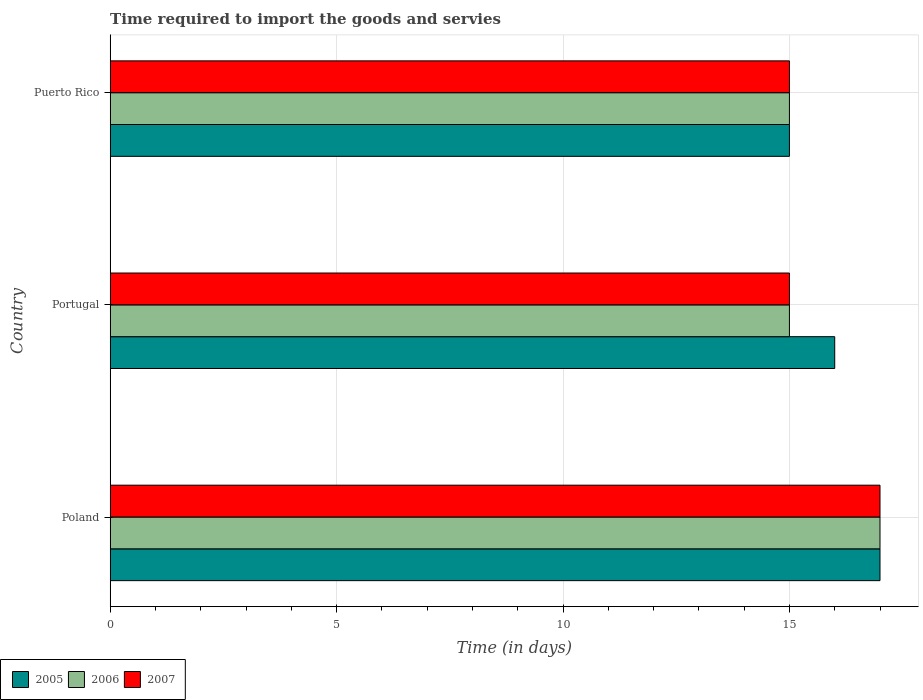How many different coloured bars are there?
Offer a very short reply. 3. How many groups of bars are there?
Your answer should be very brief. 3. Are the number of bars per tick equal to the number of legend labels?
Offer a very short reply. Yes. How many bars are there on the 2nd tick from the top?
Offer a very short reply. 3. How many bars are there on the 1st tick from the bottom?
Your answer should be very brief. 3. What is the label of the 1st group of bars from the top?
Your answer should be very brief. Puerto Rico. In how many cases, is the number of bars for a given country not equal to the number of legend labels?
Keep it short and to the point. 0. What is the number of days required to import the goods and services in 2005 in Poland?
Give a very brief answer. 17. Across all countries, what is the minimum number of days required to import the goods and services in 2005?
Your answer should be compact. 15. In which country was the number of days required to import the goods and services in 2005 minimum?
Your response must be concise. Puerto Rico. What is the total number of days required to import the goods and services in 2005 in the graph?
Your response must be concise. 48. What is the average number of days required to import the goods and services in 2006 per country?
Offer a very short reply. 15.67. What is the ratio of the number of days required to import the goods and services in 2005 in Poland to that in Puerto Rico?
Your answer should be compact. 1.13. Is the number of days required to import the goods and services in 2006 in Poland less than that in Portugal?
Provide a succinct answer. No. What is the difference between the highest and the second highest number of days required to import the goods and services in 2007?
Your answer should be compact. 2. What does the 1st bar from the top in Portugal represents?
Your answer should be very brief. 2007. What does the 1st bar from the bottom in Portugal represents?
Provide a short and direct response. 2005. Is it the case that in every country, the sum of the number of days required to import the goods and services in 2006 and number of days required to import the goods and services in 2007 is greater than the number of days required to import the goods and services in 2005?
Offer a terse response. Yes. How many bars are there?
Ensure brevity in your answer.  9. Does the graph contain any zero values?
Your answer should be compact. No. How are the legend labels stacked?
Provide a short and direct response. Horizontal. What is the title of the graph?
Give a very brief answer. Time required to import the goods and servies. What is the label or title of the X-axis?
Offer a very short reply. Time (in days). What is the label or title of the Y-axis?
Give a very brief answer. Country. What is the Time (in days) in 2005 in Poland?
Offer a terse response. 17. What is the Time (in days) in 2007 in Poland?
Make the answer very short. 17. What is the Time (in days) in 2007 in Portugal?
Provide a short and direct response. 15. What is the Time (in days) in 2005 in Puerto Rico?
Your answer should be compact. 15. What is the Time (in days) in 2007 in Puerto Rico?
Your answer should be very brief. 15. Across all countries, what is the maximum Time (in days) of 2006?
Your response must be concise. 17. Across all countries, what is the minimum Time (in days) of 2006?
Offer a terse response. 15. What is the total Time (in days) in 2005 in the graph?
Your response must be concise. 48. What is the difference between the Time (in days) of 2005 in Poland and that in Portugal?
Your answer should be compact. 1. What is the difference between the Time (in days) in 2007 in Poland and that in Portugal?
Offer a terse response. 2. What is the difference between the Time (in days) of 2005 in Portugal and that in Puerto Rico?
Give a very brief answer. 1. What is the difference between the Time (in days) of 2005 in Portugal and the Time (in days) of 2006 in Puerto Rico?
Provide a succinct answer. 1. What is the average Time (in days) of 2006 per country?
Provide a short and direct response. 15.67. What is the average Time (in days) of 2007 per country?
Your response must be concise. 15.67. What is the difference between the Time (in days) in 2005 and Time (in days) in 2006 in Poland?
Provide a succinct answer. 0. What is the difference between the Time (in days) in 2005 and Time (in days) in 2007 in Poland?
Give a very brief answer. 0. What is the difference between the Time (in days) of 2006 and Time (in days) of 2007 in Portugal?
Offer a terse response. 0. What is the difference between the Time (in days) of 2005 and Time (in days) of 2007 in Puerto Rico?
Keep it short and to the point. 0. What is the ratio of the Time (in days) in 2005 in Poland to that in Portugal?
Your answer should be very brief. 1.06. What is the ratio of the Time (in days) in 2006 in Poland to that in Portugal?
Your answer should be very brief. 1.13. What is the ratio of the Time (in days) of 2007 in Poland to that in Portugal?
Your answer should be very brief. 1.13. What is the ratio of the Time (in days) in 2005 in Poland to that in Puerto Rico?
Give a very brief answer. 1.13. What is the ratio of the Time (in days) of 2006 in Poland to that in Puerto Rico?
Provide a succinct answer. 1.13. What is the ratio of the Time (in days) in 2007 in Poland to that in Puerto Rico?
Ensure brevity in your answer.  1.13. What is the ratio of the Time (in days) in 2005 in Portugal to that in Puerto Rico?
Provide a short and direct response. 1.07. What is the ratio of the Time (in days) of 2007 in Portugal to that in Puerto Rico?
Provide a succinct answer. 1. What is the difference between the highest and the second highest Time (in days) of 2005?
Your answer should be compact. 1. What is the difference between the highest and the second highest Time (in days) of 2007?
Provide a succinct answer. 2. What is the difference between the highest and the lowest Time (in days) of 2006?
Your answer should be compact. 2. What is the difference between the highest and the lowest Time (in days) in 2007?
Your answer should be very brief. 2. 